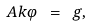<formula> <loc_0><loc_0><loc_500><loc_500>\ A k \varphi \ = \ g ,</formula> 